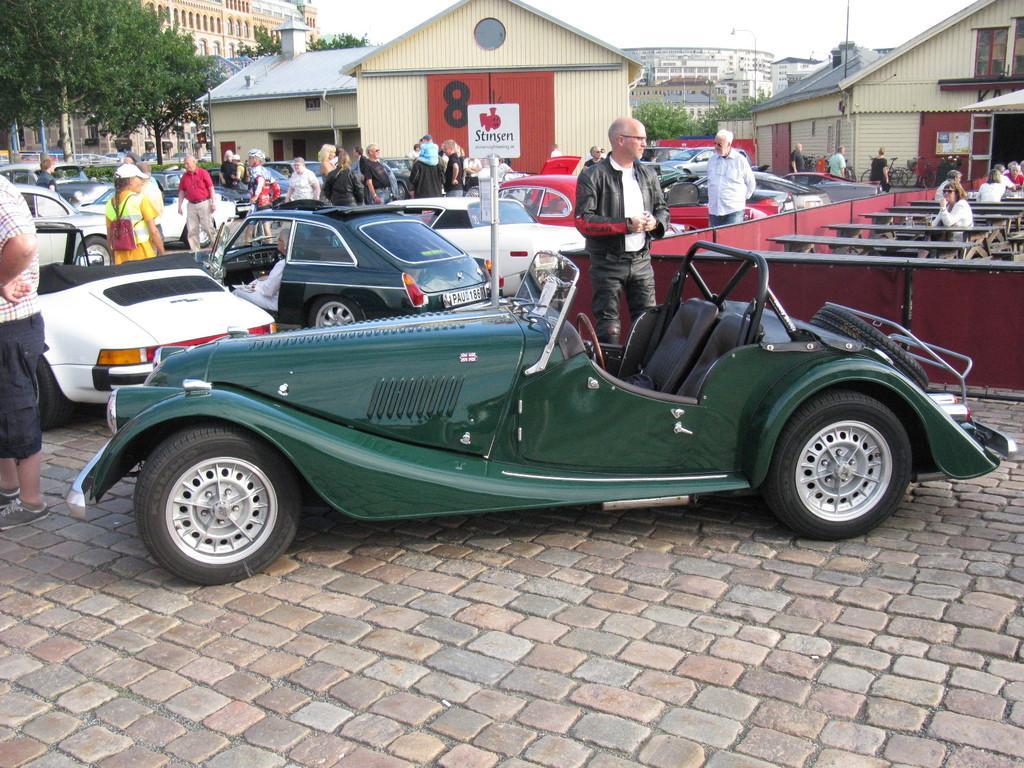Please provide a concise description of this image. In this picture I can see group of people standing. I can see vehicles, buildings and trees, and in the background there is the sky. 